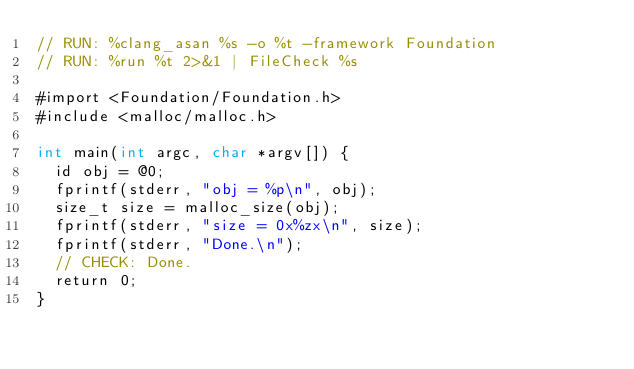<code> <loc_0><loc_0><loc_500><loc_500><_ObjectiveC_>// RUN: %clang_asan %s -o %t -framework Foundation
// RUN: %run %t 2>&1 | FileCheck %s

#import <Foundation/Foundation.h>
#include <malloc/malloc.h>

int main(int argc, char *argv[]) {
  id obj = @0;
  fprintf(stderr, "obj = %p\n", obj);
  size_t size = malloc_size(obj);
  fprintf(stderr, "size = 0x%zx\n", size);
  fprintf(stderr, "Done.\n");
  // CHECK: Done.
  return 0;
}
</code> 